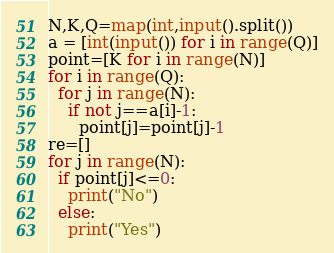Convert code to text. <code><loc_0><loc_0><loc_500><loc_500><_Python_>N,K,Q=map(int,input().split())
a = [int(input()) for i in range(Q)]
point=[K for i in range(N)]
for i in range(Q):
  for j in range(N):
    if not j==a[i]-1:
      point[j]=point[j]-1
re=[]
for j in range(N):
  if point[j]<=0:
    print("No")
  else:
    print("Yes")</code> 